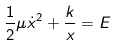Convert formula to latex. <formula><loc_0><loc_0><loc_500><loc_500>\frac { 1 } { 2 } \mu \dot { x } ^ { 2 } + \frac { k } { x } = E</formula> 